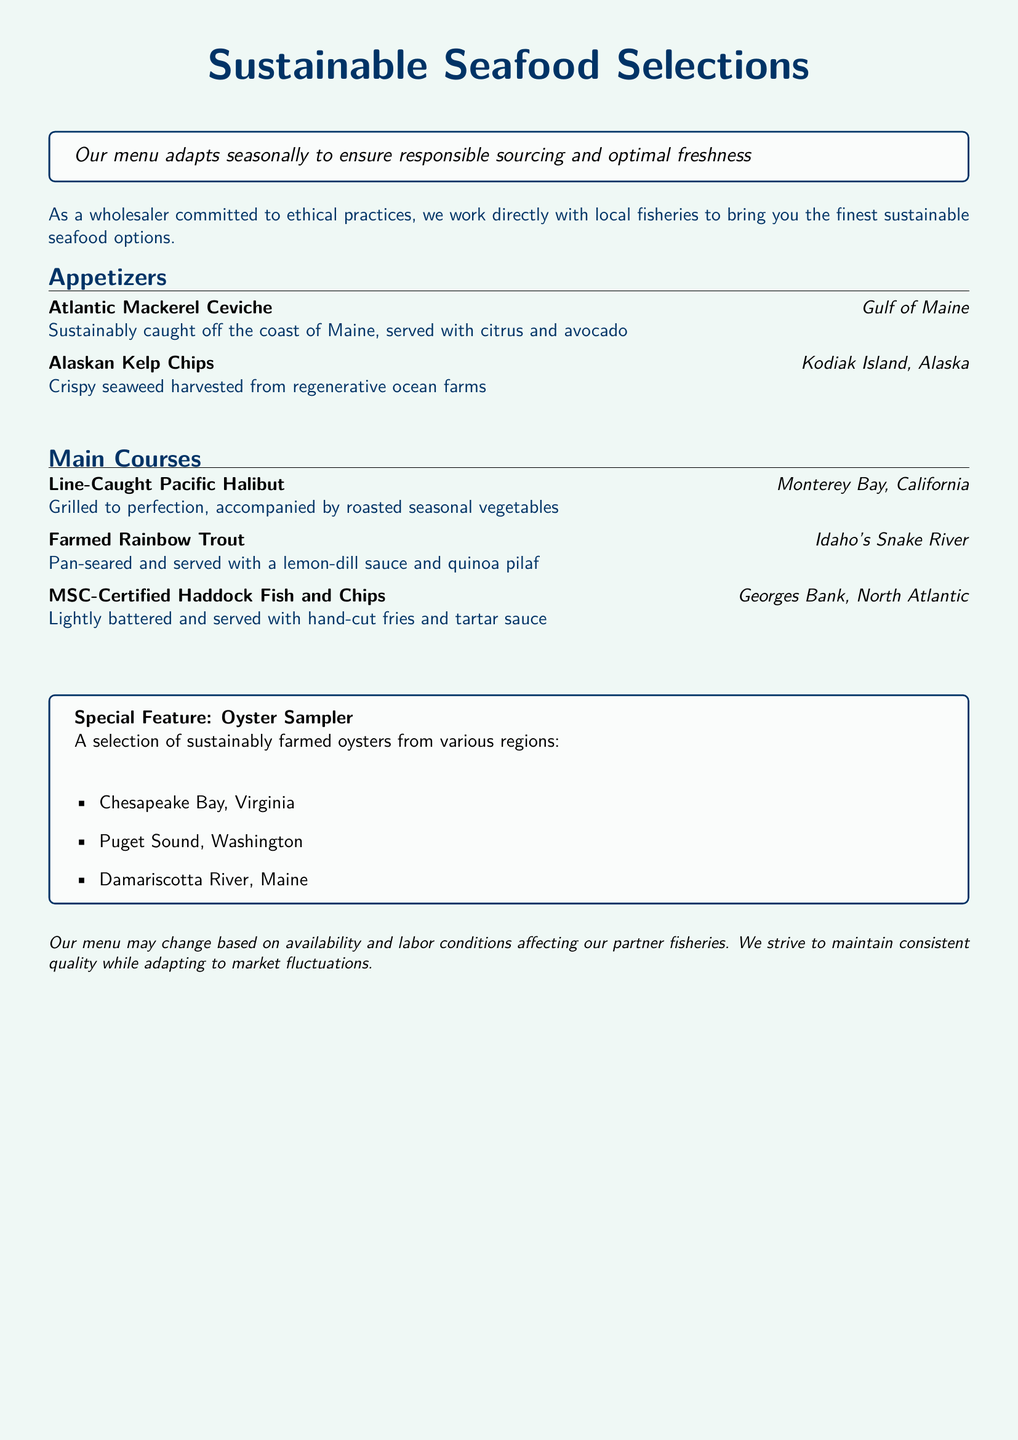What is the title of the menu? The title of the menu is presented prominently at the top and is "Sustainable Seafood Selections."
Answer: Sustainable Seafood Selections Where is the Atlantic Mackerel Ceviche sourced from? The sourcing information for the Atlantic Mackerel Ceviche indicates it is from the Gulf of Maine.
Answer: Gulf of Maine What type of oysters are featured in the special selection? The menu describes the special feature as a selection of sustainably farmed oysters.
Answer: Sustainably farmed oysters Which fish is highlighted as MSC-Certified? The menu specifically mentions MSC-Certified Haddock Fish and Chips as one of the main courses.
Answer: Haddock What region is the Farmed Rainbow Trout sourced from? The sourcing information for the Farmed Rainbow Trout notes it is from Idaho's Snake River.
Answer: Idaho's Snake River What does MSC stand for in the context of the menu? MSC refers to the Marine Stewardship Council, which certifies sustainable fishing practices.
Answer: Marine Stewardship Council How many regions are oysters sourced from in the sampler? The menu lists three regions from which the oysters are sourced for the sampler.
Answer: Three What is the primary theme of the menu? The primary theme of the menu is sustainable seafood selections that adapt seasonally.
Answer: Sustainable seafood selections 